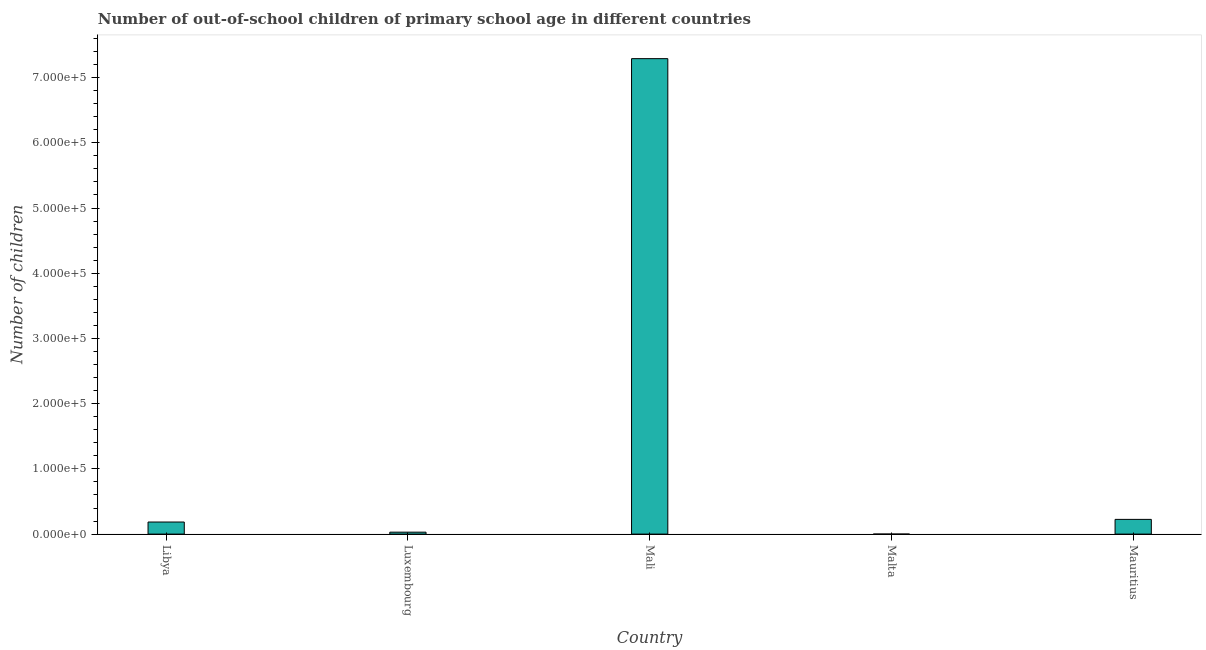Does the graph contain grids?
Provide a succinct answer. No. What is the title of the graph?
Your answer should be compact. Number of out-of-school children of primary school age in different countries. What is the label or title of the Y-axis?
Provide a short and direct response. Number of children. What is the number of out-of-school children in Mali?
Keep it short and to the point. 7.29e+05. Across all countries, what is the maximum number of out-of-school children?
Provide a short and direct response. 7.29e+05. Across all countries, what is the minimum number of out-of-school children?
Your response must be concise. 19. In which country was the number of out-of-school children maximum?
Provide a succinct answer. Mali. In which country was the number of out-of-school children minimum?
Your answer should be compact. Malta. What is the sum of the number of out-of-school children?
Make the answer very short. 7.73e+05. What is the difference between the number of out-of-school children in Luxembourg and Malta?
Your answer should be compact. 2944. What is the average number of out-of-school children per country?
Offer a very short reply. 1.55e+05. What is the median number of out-of-school children?
Your answer should be compact. 1.85e+04. In how many countries, is the number of out-of-school children greater than 240000 ?
Provide a succinct answer. 1. What is the ratio of the number of out-of-school children in Libya to that in Mali?
Your answer should be very brief. 0.03. Is the difference between the number of out-of-school children in Libya and Mauritius greater than the difference between any two countries?
Give a very brief answer. No. What is the difference between the highest and the second highest number of out-of-school children?
Provide a short and direct response. 7.07e+05. What is the difference between the highest and the lowest number of out-of-school children?
Your answer should be compact. 7.29e+05. How many bars are there?
Provide a succinct answer. 5. Are the values on the major ticks of Y-axis written in scientific E-notation?
Offer a very short reply. Yes. What is the Number of children in Libya?
Your answer should be compact. 1.85e+04. What is the Number of children in Luxembourg?
Offer a very short reply. 2963. What is the Number of children in Mali?
Offer a terse response. 7.29e+05. What is the Number of children of Mauritius?
Your response must be concise. 2.26e+04. What is the difference between the Number of children in Libya and Luxembourg?
Give a very brief answer. 1.56e+04. What is the difference between the Number of children in Libya and Mali?
Give a very brief answer. -7.11e+05. What is the difference between the Number of children in Libya and Malta?
Provide a short and direct response. 1.85e+04. What is the difference between the Number of children in Libya and Mauritius?
Your answer should be very brief. -4039. What is the difference between the Number of children in Luxembourg and Mali?
Make the answer very short. -7.26e+05. What is the difference between the Number of children in Luxembourg and Malta?
Make the answer very short. 2944. What is the difference between the Number of children in Luxembourg and Mauritius?
Make the answer very short. -1.96e+04. What is the difference between the Number of children in Mali and Malta?
Give a very brief answer. 7.29e+05. What is the difference between the Number of children in Mali and Mauritius?
Ensure brevity in your answer.  7.07e+05. What is the difference between the Number of children in Malta and Mauritius?
Make the answer very short. -2.26e+04. What is the ratio of the Number of children in Libya to that in Luxembourg?
Offer a very short reply. 6.25. What is the ratio of the Number of children in Libya to that in Mali?
Give a very brief answer. 0.03. What is the ratio of the Number of children in Libya to that in Malta?
Keep it short and to the point. 975.26. What is the ratio of the Number of children in Libya to that in Mauritius?
Offer a terse response. 0.82. What is the ratio of the Number of children in Luxembourg to that in Mali?
Your answer should be compact. 0. What is the ratio of the Number of children in Luxembourg to that in Malta?
Provide a succinct answer. 155.95. What is the ratio of the Number of children in Luxembourg to that in Mauritius?
Provide a succinct answer. 0.13. What is the ratio of the Number of children in Mali to that in Malta?
Your answer should be compact. 3.84e+04. What is the ratio of the Number of children in Mali to that in Mauritius?
Your response must be concise. 32.3. What is the ratio of the Number of children in Malta to that in Mauritius?
Ensure brevity in your answer.  0. 